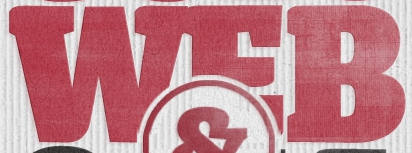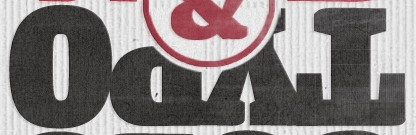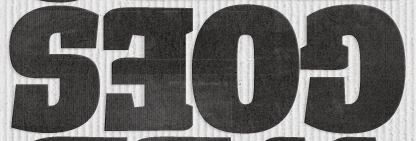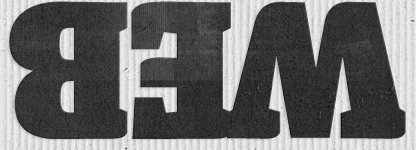Transcribe the words shown in these images in order, separated by a semicolon. WEB; TYPO; GOES; WEB 